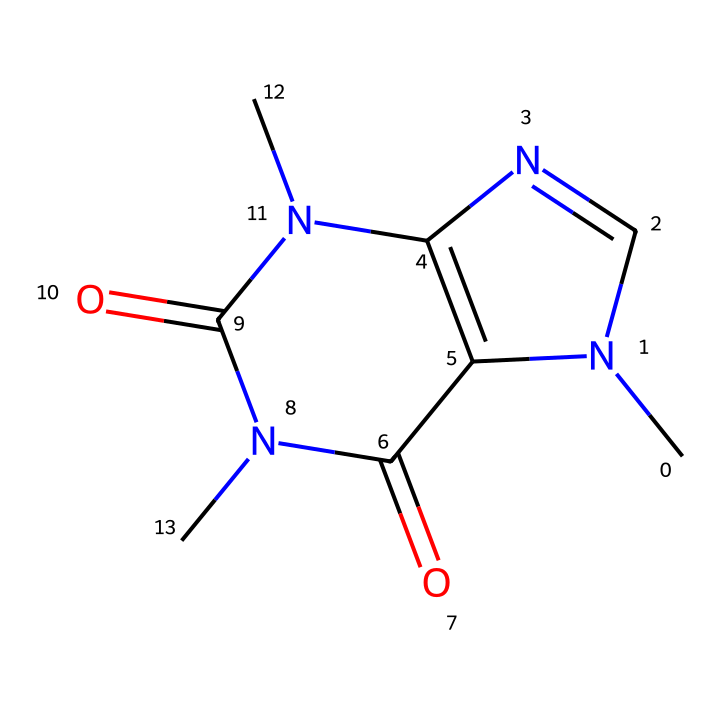What is the molecular formula of caffeine? To derive the molecular formula, we count the atoms from the chemical structure represented in the SMILES notation. This structure has 8 carbon (C), 10 hydrogen (H), 4 nitrogen (N), and 2 oxygen (O) atoms. Thus, the molecular formula is C8H10N4O2.
Answer: C8H10N4O2 How many nitrogen atoms are present in the caffeine structure? We can identify the nitrogen atoms in the SMILES representation, where 'N' denotes the presence of nitrogen elements. Counting these gives us a total of 4 nitrogen atoms.
Answer: 4 Is caffeine a type of alkaloid? Caffeine is classified as an alkaloid due to the presence of nitrogen in a heterocyclic structure, which is typical for alkaloids. In this case, the nitrogen atoms contribute to its basic properties.
Answer: yes What is the total number of rings in the caffeine structure? Examining the structure, we observe two distinct cyclic components. The presence of two rings is indicative of the bicyclic nature of caffeine.
Answer: 2 Does this chemical structure indicate any hydrogen bonding potential? The presence of nitrogen and oxygen atoms in the structure suggests potential hydrogen bonding sites, particularly from the amine and carbonyl functional groups. These groups can form hydrogen bonds with other molecules, contributing to the chemical's solubility and biological activity.
Answer: yes What type of compounds does caffeine belong to? Caffeine belongs to the class of compounds known as xanthines, which are characterized by their bicyclic structure and presence of nitrogen atoms. This specific structure aligns with the properties of purine derivatives, further classified as stimulants.
Answer: xanthines 